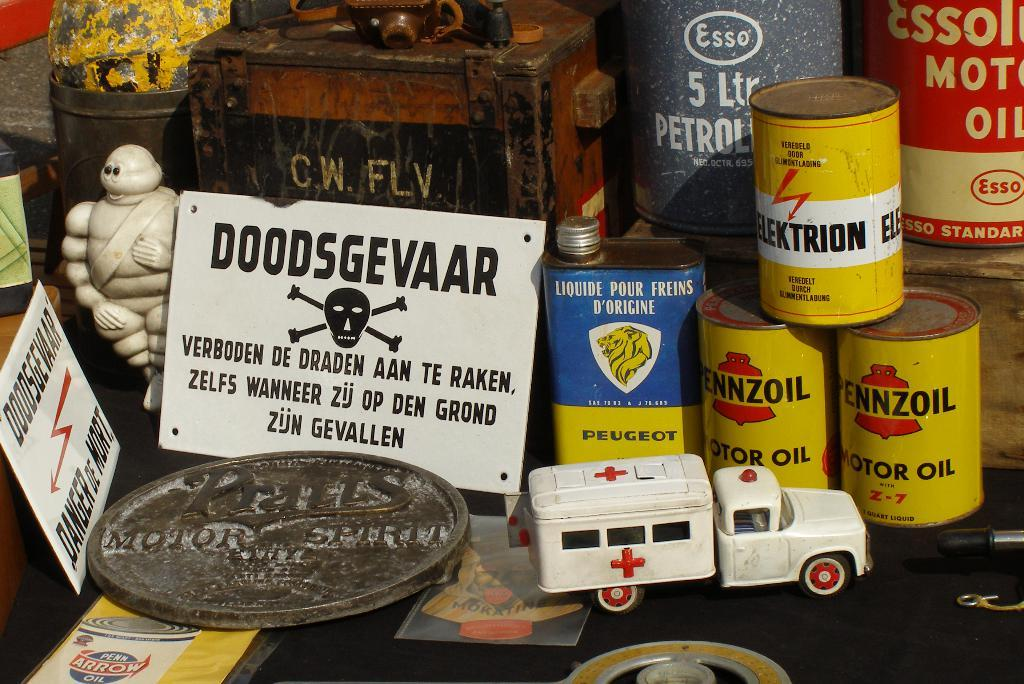<image>
Summarize the visual content of the image. A collection of old items including some rusted cans of Penzoil oil. 